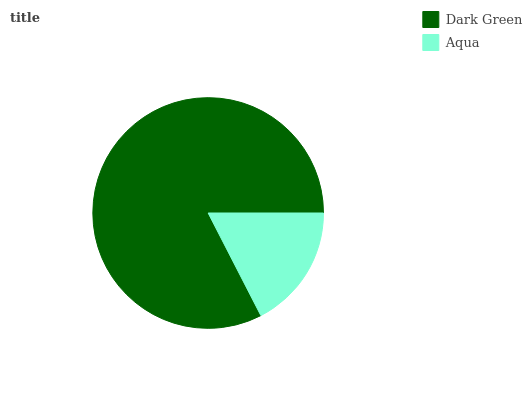Is Aqua the minimum?
Answer yes or no. Yes. Is Dark Green the maximum?
Answer yes or no. Yes. Is Aqua the maximum?
Answer yes or no. No. Is Dark Green greater than Aqua?
Answer yes or no. Yes. Is Aqua less than Dark Green?
Answer yes or no. Yes. Is Aqua greater than Dark Green?
Answer yes or no. No. Is Dark Green less than Aqua?
Answer yes or no. No. Is Dark Green the high median?
Answer yes or no. Yes. Is Aqua the low median?
Answer yes or no. Yes. Is Aqua the high median?
Answer yes or no. No. Is Dark Green the low median?
Answer yes or no. No. 